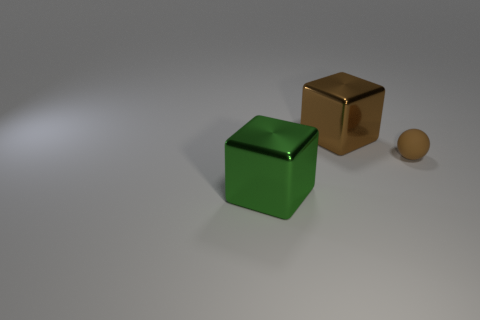Add 2 small brown rubber objects. How many objects exist? 5 Subtract all spheres. How many objects are left? 2 Subtract 0 cyan cubes. How many objects are left? 3 Subtract all metallic things. Subtract all large shiny spheres. How many objects are left? 1 Add 3 big green blocks. How many big green blocks are left? 4 Add 1 small brown matte balls. How many small brown matte balls exist? 2 